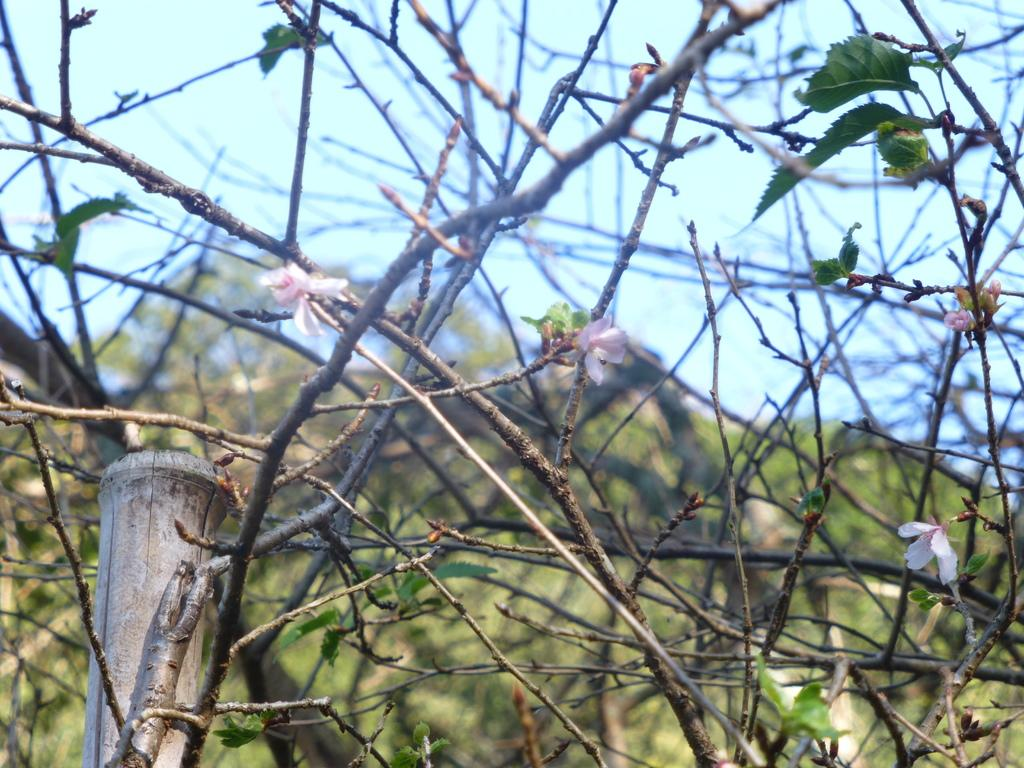What type of vegetation can be seen in the image? There are trees, leaves, and flowers in the image. What part of the natural environment is visible in the image? The sky is visible in the image. What might be the reason for the object appearing truncated towards the bottom of the image? It is unclear from the provided facts why the object appears truncated, but it could be due to the angle or perspective of the image. Can you see a nest in the image? There is no mention of a nest in the provided facts, so it cannot be confirmed whether a nest is present in the image. 